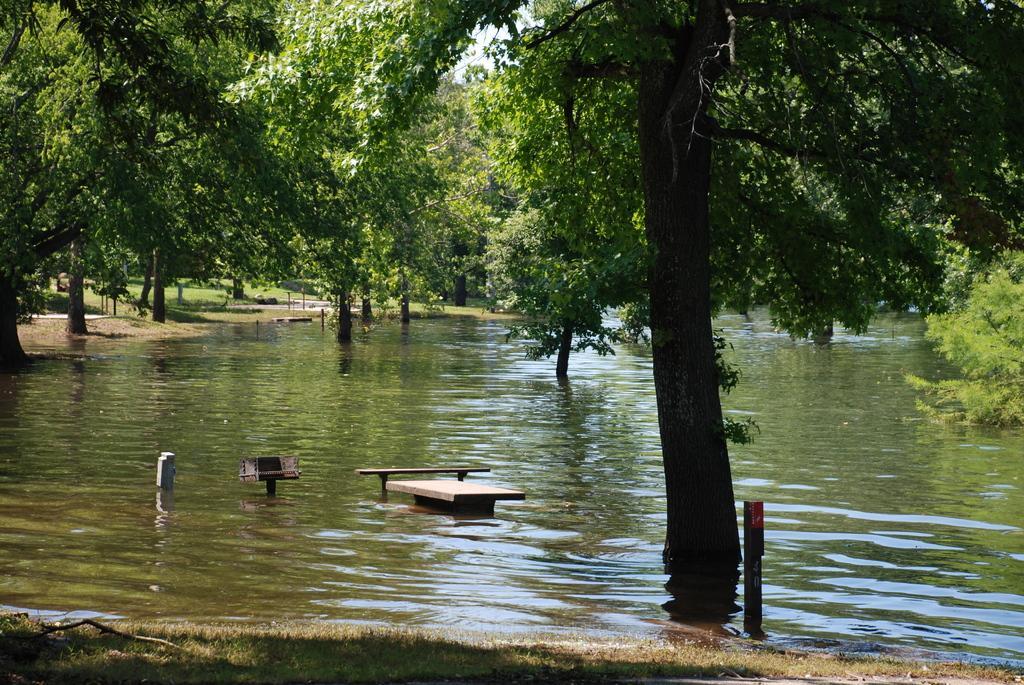In one or two sentences, can you explain what this image depicts? Here, we can see water and there are some green trees. 